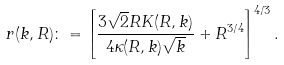<formula> <loc_0><loc_0><loc_500><loc_500>r ( k , R ) \colon = \left [ \frac { 3 \sqrt { 2 } R K ( R , k ) } { 4 \kappa ( R , k ) \sqrt { k } } + R ^ { 3 / 4 } \right ] ^ { 4 / 3 } .</formula> 